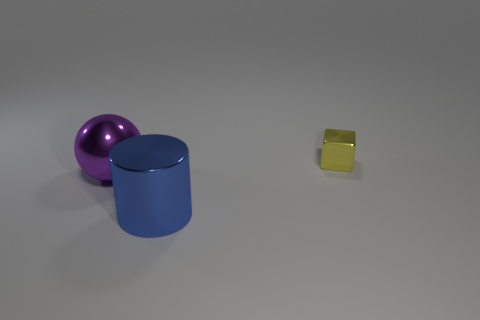There is a thing that is the same size as the shiny cylinder; what shape is it?
Your answer should be very brief. Sphere. Are there any big matte balls of the same color as the block?
Your answer should be very brief. No. The yellow metal cube has what size?
Your answer should be very brief. Small. Is the big cylinder made of the same material as the tiny object?
Offer a very short reply. Yes. How many things are left of the big metal object in front of the object that is to the left of the metal cylinder?
Your answer should be very brief. 1. The large metal thing behind the blue shiny cylinder has what shape?
Your response must be concise. Sphere. How many other objects are the same material as the purple object?
Provide a short and direct response. 2. Is the color of the metallic cylinder the same as the ball?
Offer a very short reply. No. Are there fewer small yellow metal things in front of the purple metallic object than tiny metallic objects that are in front of the cylinder?
Keep it short and to the point. No. Does the metal object to the left of the shiny cylinder have the same size as the small cube?
Give a very brief answer. No. 